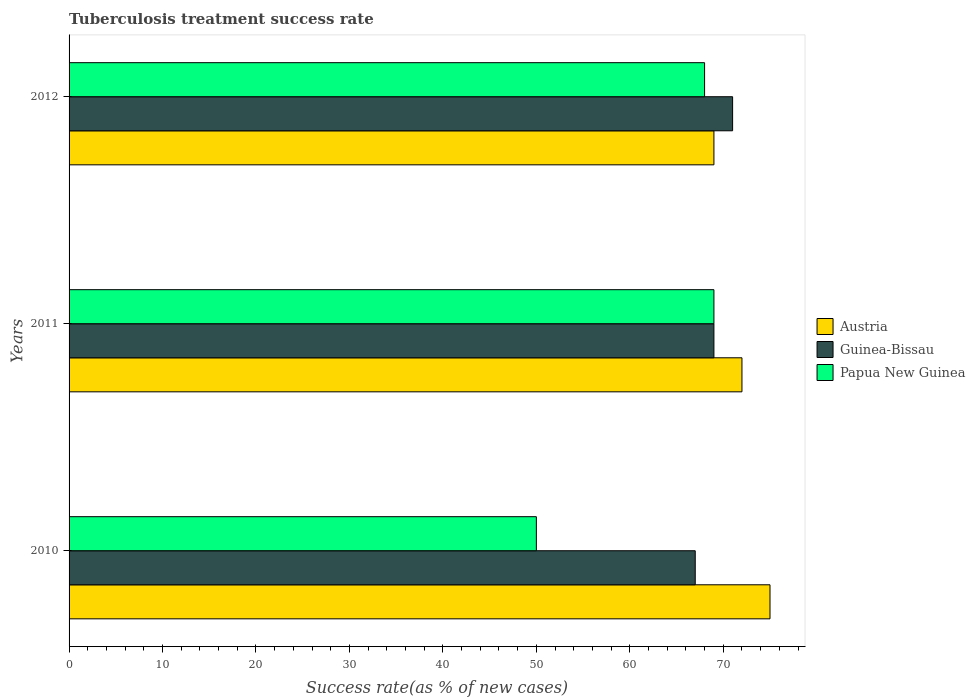How many groups of bars are there?
Offer a very short reply. 3. Are the number of bars per tick equal to the number of legend labels?
Keep it short and to the point. Yes. Are the number of bars on each tick of the Y-axis equal?
Give a very brief answer. Yes. How many bars are there on the 1st tick from the top?
Make the answer very short. 3. How many bars are there on the 3rd tick from the bottom?
Your response must be concise. 3. Across all years, what is the maximum tuberculosis treatment success rate in Guinea-Bissau?
Offer a terse response. 71. In which year was the tuberculosis treatment success rate in Guinea-Bissau maximum?
Your answer should be very brief. 2012. What is the total tuberculosis treatment success rate in Austria in the graph?
Ensure brevity in your answer.  216. What is the average tuberculosis treatment success rate in Papua New Guinea per year?
Keep it short and to the point. 62.33. What is the ratio of the tuberculosis treatment success rate in Guinea-Bissau in 2011 to that in 2012?
Your answer should be compact. 0.97. Is the tuberculosis treatment success rate in Guinea-Bissau in 2011 less than that in 2012?
Make the answer very short. Yes. Is the difference between the tuberculosis treatment success rate in Austria in 2011 and 2012 greater than the difference between the tuberculosis treatment success rate in Papua New Guinea in 2011 and 2012?
Offer a terse response. Yes. What is the difference between the highest and the second highest tuberculosis treatment success rate in Austria?
Offer a very short reply. 3. What is the difference between the highest and the lowest tuberculosis treatment success rate in Papua New Guinea?
Ensure brevity in your answer.  19. In how many years, is the tuberculosis treatment success rate in Papua New Guinea greater than the average tuberculosis treatment success rate in Papua New Guinea taken over all years?
Offer a very short reply. 2. Is the sum of the tuberculosis treatment success rate in Papua New Guinea in 2010 and 2011 greater than the maximum tuberculosis treatment success rate in Austria across all years?
Provide a short and direct response. Yes. What does the 2nd bar from the bottom in 2011 represents?
Your answer should be very brief. Guinea-Bissau. Is it the case that in every year, the sum of the tuberculosis treatment success rate in Guinea-Bissau and tuberculosis treatment success rate in Papua New Guinea is greater than the tuberculosis treatment success rate in Austria?
Your answer should be very brief. Yes. What is the difference between two consecutive major ticks on the X-axis?
Ensure brevity in your answer.  10. Does the graph contain any zero values?
Provide a short and direct response. No. How many legend labels are there?
Your answer should be very brief. 3. How are the legend labels stacked?
Ensure brevity in your answer.  Vertical. What is the title of the graph?
Give a very brief answer. Tuberculosis treatment success rate. Does "Faeroe Islands" appear as one of the legend labels in the graph?
Your response must be concise. No. What is the label or title of the X-axis?
Your answer should be compact. Success rate(as % of new cases). What is the label or title of the Y-axis?
Your response must be concise. Years. What is the Success rate(as % of new cases) of Austria in 2010?
Offer a very short reply. 75. What is the Success rate(as % of new cases) in Papua New Guinea in 2010?
Your answer should be compact. 50. What is the Success rate(as % of new cases) of Austria in 2011?
Your response must be concise. 72. What is the Success rate(as % of new cases) in Austria in 2012?
Ensure brevity in your answer.  69. Across all years, what is the maximum Success rate(as % of new cases) in Austria?
Offer a terse response. 75. Across all years, what is the maximum Success rate(as % of new cases) of Guinea-Bissau?
Make the answer very short. 71. Across all years, what is the minimum Success rate(as % of new cases) of Papua New Guinea?
Ensure brevity in your answer.  50. What is the total Success rate(as % of new cases) in Austria in the graph?
Provide a succinct answer. 216. What is the total Success rate(as % of new cases) in Guinea-Bissau in the graph?
Give a very brief answer. 207. What is the total Success rate(as % of new cases) of Papua New Guinea in the graph?
Give a very brief answer. 187. What is the difference between the Success rate(as % of new cases) in Austria in 2010 and that in 2011?
Your answer should be compact. 3. What is the difference between the Success rate(as % of new cases) of Guinea-Bissau in 2010 and that in 2012?
Give a very brief answer. -4. What is the difference between the Success rate(as % of new cases) in Papua New Guinea in 2010 and that in 2012?
Provide a succinct answer. -18. What is the difference between the Success rate(as % of new cases) in Austria in 2011 and that in 2012?
Keep it short and to the point. 3. What is the difference between the Success rate(as % of new cases) in Guinea-Bissau in 2011 and that in 2012?
Offer a terse response. -2. What is the difference between the Success rate(as % of new cases) of Papua New Guinea in 2011 and that in 2012?
Provide a succinct answer. 1. What is the difference between the Success rate(as % of new cases) in Austria in 2010 and the Success rate(as % of new cases) in Guinea-Bissau in 2011?
Give a very brief answer. 6. What is the difference between the Success rate(as % of new cases) in Austria in 2010 and the Success rate(as % of new cases) in Papua New Guinea in 2011?
Provide a short and direct response. 6. What is the difference between the Success rate(as % of new cases) in Guinea-Bissau in 2010 and the Success rate(as % of new cases) in Papua New Guinea in 2012?
Offer a very short reply. -1. What is the difference between the Success rate(as % of new cases) in Austria in 2011 and the Success rate(as % of new cases) in Papua New Guinea in 2012?
Offer a very short reply. 4. What is the difference between the Success rate(as % of new cases) of Guinea-Bissau in 2011 and the Success rate(as % of new cases) of Papua New Guinea in 2012?
Give a very brief answer. 1. What is the average Success rate(as % of new cases) in Papua New Guinea per year?
Your answer should be compact. 62.33. In the year 2010, what is the difference between the Success rate(as % of new cases) in Austria and Success rate(as % of new cases) in Papua New Guinea?
Keep it short and to the point. 25. In the year 2010, what is the difference between the Success rate(as % of new cases) in Guinea-Bissau and Success rate(as % of new cases) in Papua New Guinea?
Provide a succinct answer. 17. In the year 2011, what is the difference between the Success rate(as % of new cases) in Austria and Success rate(as % of new cases) in Guinea-Bissau?
Offer a terse response. 3. In the year 2011, what is the difference between the Success rate(as % of new cases) in Austria and Success rate(as % of new cases) in Papua New Guinea?
Ensure brevity in your answer.  3. In the year 2011, what is the difference between the Success rate(as % of new cases) in Guinea-Bissau and Success rate(as % of new cases) in Papua New Guinea?
Offer a very short reply. 0. In the year 2012, what is the difference between the Success rate(as % of new cases) in Austria and Success rate(as % of new cases) in Guinea-Bissau?
Provide a succinct answer. -2. In the year 2012, what is the difference between the Success rate(as % of new cases) of Austria and Success rate(as % of new cases) of Papua New Guinea?
Your answer should be compact. 1. What is the ratio of the Success rate(as % of new cases) of Austria in 2010 to that in 2011?
Give a very brief answer. 1.04. What is the ratio of the Success rate(as % of new cases) of Papua New Guinea in 2010 to that in 2011?
Your answer should be very brief. 0.72. What is the ratio of the Success rate(as % of new cases) in Austria in 2010 to that in 2012?
Your response must be concise. 1.09. What is the ratio of the Success rate(as % of new cases) of Guinea-Bissau in 2010 to that in 2012?
Your answer should be very brief. 0.94. What is the ratio of the Success rate(as % of new cases) in Papua New Guinea in 2010 to that in 2012?
Make the answer very short. 0.74. What is the ratio of the Success rate(as % of new cases) of Austria in 2011 to that in 2012?
Ensure brevity in your answer.  1.04. What is the ratio of the Success rate(as % of new cases) in Guinea-Bissau in 2011 to that in 2012?
Keep it short and to the point. 0.97. What is the ratio of the Success rate(as % of new cases) of Papua New Guinea in 2011 to that in 2012?
Ensure brevity in your answer.  1.01. What is the difference between the highest and the lowest Success rate(as % of new cases) in Austria?
Your response must be concise. 6. What is the difference between the highest and the lowest Success rate(as % of new cases) of Guinea-Bissau?
Offer a very short reply. 4. 